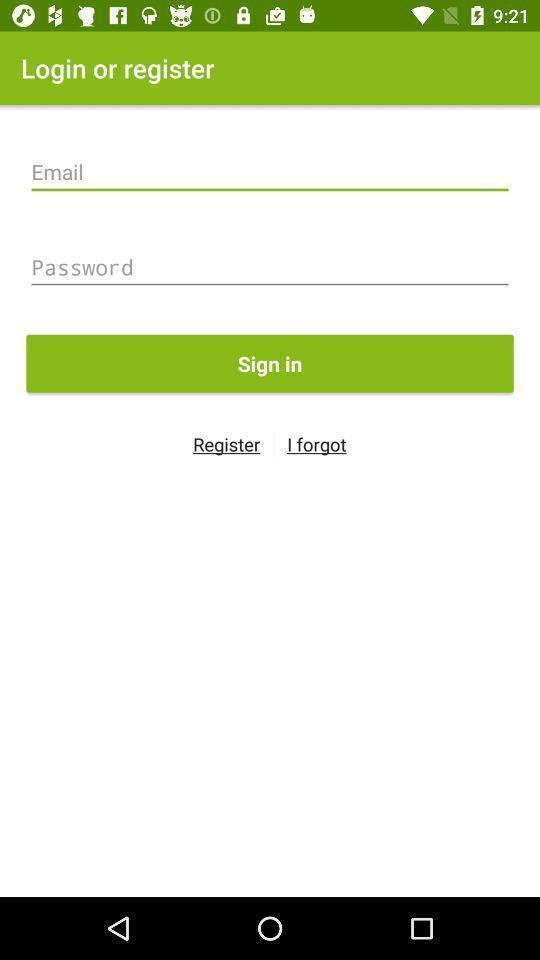Give me a summary of this screen capture. Sign in page. 